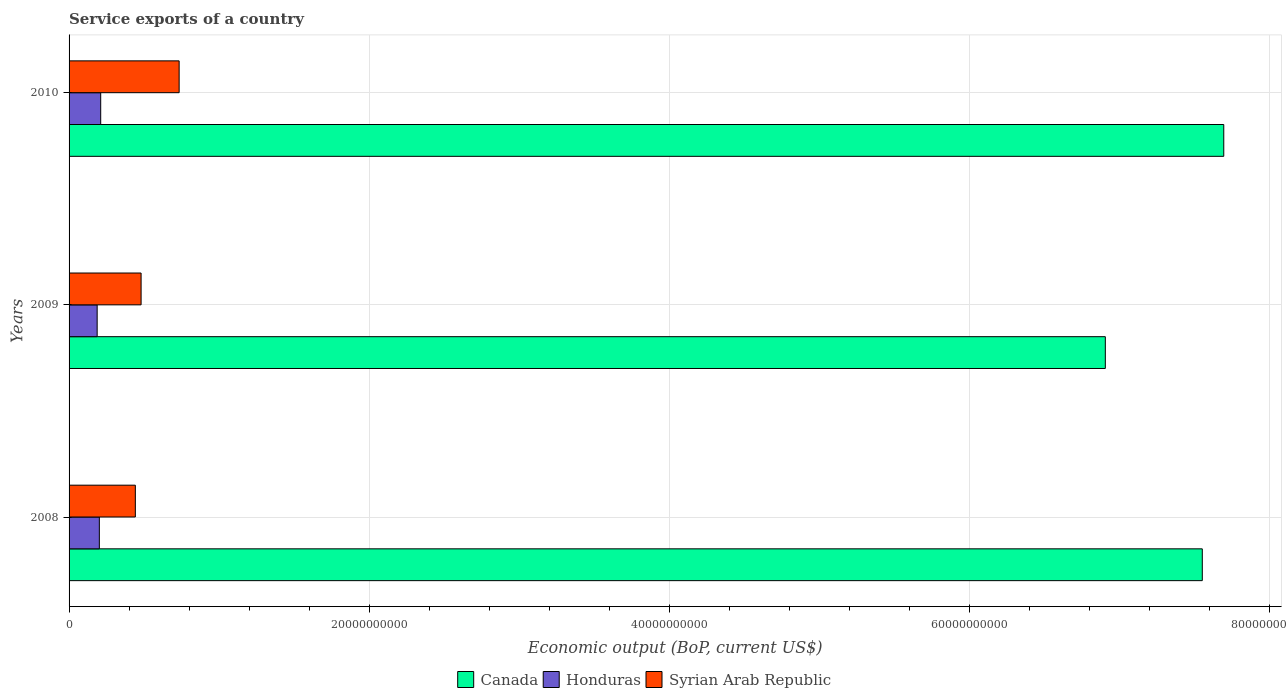How many different coloured bars are there?
Offer a very short reply. 3. Are the number of bars per tick equal to the number of legend labels?
Make the answer very short. Yes. How many bars are there on the 1st tick from the bottom?
Offer a very short reply. 3. What is the service exports in Canada in 2008?
Make the answer very short. 7.55e+1. Across all years, what is the maximum service exports in Canada?
Offer a very short reply. 7.69e+1. Across all years, what is the minimum service exports in Syrian Arab Republic?
Provide a succinct answer. 4.42e+09. In which year was the service exports in Canada maximum?
Ensure brevity in your answer.  2010. What is the total service exports in Honduras in the graph?
Offer a very short reply. 6.00e+09. What is the difference between the service exports in Canada in 2008 and that in 2010?
Keep it short and to the point. -1.43e+09. What is the difference between the service exports in Canada in 2010 and the service exports in Syrian Arab Republic in 2009?
Your answer should be compact. 7.21e+1. What is the average service exports in Canada per year?
Ensure brevity in your answer.  7.38e+1. In the year 2009, what is the difference between the service exports in Canada and service exports in Honduras?
Provide a short and direct response. 6.72e+1. What is the ratio of the service exports in Canada in 2008 to that in 2009?
Your answer should be compact. 1.09. Is the service exports in Syrian Arab Republic in 2008 less than that in 2010?
Your answer should be compact. Yes. What is the difference between the highest and the second highest service exports in Canada?
Offer a very short reply. 1.43e+09. What is the difference between the highest and the lowest service exports in Syrian Arab Republic?
Keep it short and to the point. 2.92e+09. In how many years, is the service exports in Syrian Arab Republic greater than the average service exports in Syrian Arab Republic taken over all years?
Give a very brief answer. 1. Is the sum of the service exports in Syrian Arab Republic in 2008 and 2010 greater than the maximum service exports in Honduras across all years?
Provide a succinct answer. Yes. What does the 3rd bar from the top in 2010 represents?
Your answer should be very brief. Canada. What does the 1st bar from the bottom in 2009 represents?
Provide a succinct answer. Canada. How many bars are there?
Provide a short and direct response. 9. Are all the bars in the graph horizontal?
Offer a terse response. Yes. Are the values on the major ticks of X-axis written in scientific E-notation?
Ensure brevity in your answer.  No. How are the legend labels stacked?
Make the answer very short. Horizontal. What is the title of the graph?
Offer a very short reply. Service exports of a country. Does "Nepal" appear as one of the legend labels in the graph?
Your answer should be compact. No. What is the label or title of the X-axis?
Give a very brief answer. Economic output (BoP, current US$). What is the label or title of the Y-axis?
Give a very brief answer. Years. What is the Economic output (BoP, current US$) in Canada in 2008?
Ensure brevity in your answer.  7.55e+1. What is the Economic output (BoP, current US$) in Honduras in 2008?
Your answer should be very brief. 2.02e+09. What is the Economic output (BoP, current US$) of Syrian Arab Republic in 2008?
Give a very brief answer. 4.42e+09. What is the Economic output (BoP, current US$) of Canada in 2009?
Your answer should be very brief. 6.90e+1. What is the Economic output (BoP, current US$) of Honduras in 2009?
Give a very brief answer. 1.87e+09. What is the Economic output (BoP, current US$) in Syrian Arab Republic in 2009?
Provide a succinct answer. 4.80e+09. What is the Economic output (BoP, current US$) in Canada in 2010?
Give a very brief answer. 7.69e+1. What is the Economic output (BoP, current US$) of Honduras in 2010?
Offer a terse response. 2.11e+09. What is the Economic output (BoP, current US$) in Syrian Arab Republic in 2010?
Provide a short and direct response. 7.33e+09. Across all years, what is the maximum Economic output (BoP, current US$) of Canada?
Your answer should be compact. 7.69e+1. Across all years, what is the maximum Economic output (BoP, current US$) in Honduras?
Provide a succinct answer. 2.11e+09. Across all years, what is the maximum Economic output (BoP, current US$) in Syrian Arab Republic?
Keep it short and to the point. 7.33e+09. Across all years, what is the minimum Economic output (BoP, current US$) in Canada?
Your answer should be compact. 6.90e+1. Across all years, what is the minimum Economic output (BoP, current US$) in Honduras?
Your answer should be very brief. 1.87e+09. Across all years, what is the minimum Economic output (BoP, current US$) in Syrian Arab Republic?
Offer a terse response. 4.42e+09. What is the total Economic output (BoP, current US$) in Canada in the graph?
Keep it short and to the point. 2.21e+11. What is the total Economic output (BoP, current US$) of Honduras in the graph?
Provide a short and direct response. 6.00e+09. What is the total Economic output (BoP, current US$) in Syrian Arab Republic in the graph?
Give a very brief answer. 1.65e+1. What is the difference between the Economic output (BoP, current US$) of Canada in 2008 and that in 2009?
Make the answer very short. 6.46e+09. What is the difference between the Economic output (BoP, current US$) of Honduras in 2008 and that in 2009?
Offer a terse response. 1.46e+08. What is the difference between the Economic output (BoP, current US$) in Syrian Arab Republic in 2008 and that in 2009?
Give a very brief answer. -3.83e+08. What is the difference between the Economic output (BoP, current US$) in Canada in 2008 and that in 2010?
Provide a short and direct response. -1.43e+09. What is the difference between the Economic output (BoP, current US$) in Honduras in 2008 and that in 2010?
Give a very brief answer. -9.05e+07. What is the difference between the Economic output (BoP, current US$) of Syrian Arab Republic in 2008 and that in 2010?
Provide a short and direct response. -2.92e+09. What is the difference between the Economic output (BoP, current US$) of Canada in 2009 and that in 2010?
Provide a succinct answer. -7.89e+09. What is the difference between the Economic output (BoP, current US$) of Honduras in 2009 and that in 2010?
Your response must be concise. -2.36e+08. What is the difference between the Economic output (BoP, current US$) in Syrian Arab Republic in 2009 and that in 2010?
Provide a succinct answer. -2.53e+09. What is the difference between the Economic output (BoP, current US$) of Canada in 2008 and the Economic output (BoP, current US$) of Honduras in 2009?
Offer a very short reply. 7.36e+1. What is the difference between the Economic output (BoP, current US$) of Canada in 2008 and the Economic output (BoP, current US$) of Syrian Arab Republic in 2009?
Ensure brevity in your answer.  7.07e+1. What is the difference between the Economic output (BoP, current US$) in Honduras in 2008 and the Economic output (BoP, current US$) in Syrian Arab Republic in 2009?
Provide a succinct answer. -2.78e+09. What is the difference between the Economic output (BoP, current US$) of Canada in 2008 and the Economic output (BoP, current US$) of Honduras in 2010?
Offer a very short reply. 7.34e+1. What is the difference between the Economic output (BoP, current US$) in Canada in 2008 and the Economic output (BoP, current US$) in Syrian Arab Republic in 2010?
Your answer should be very brief. 6.82e+1. What is the difference between the Economic output (BoP, current US$) of Honduras in 2008 and the Economic output (BoP, current US$) of Syrian Arab Republic in 2010?
Provide a succinct answer. -5.32e+09. What is the difference between the Economic output (BoP, current US$) of Canada in 2009 and the Economic output (BoP, current US$) of Honduras in 2010?
Your answer should be compact. 6.69e+1. What is the difference between the Economic output (BoP, current US$) of Canada in 2009 and the Economic output (BoP, current US$) of Syrian Arab Republic in 2010?
Make the answer very short. 6.17e+1. What is the difference between the Economic output (BoP, current US$) of Honduras in 2009 and the Economic output (BoP, current US$) of Syrian Arab Republic in 2010?
Make the answer very short. -5.46e+09. What is the average Economic output (BoP, current US$) in Canada per year?
Give a very brief answer. 7.38e+1. What is the average Economic output (BoP, current US$) in Honduras per year?
Offer a terse response. 2.00e+09. What is the average Economic output (BoP, current US$) in Syrian Arab Republic per year?
Keep it short and to the point. 5.52e+09. In the year 2008, what is the difference between the Economic output (BoP, current US$) in Canada and Economic output (BoP, current US$) in Honduras?
Provide a short and direct response. 7.35e+1. In the year 2008, what is the difference between the Economic output (BoP, current US$) of Canada and Economic output (BoP, current US$) of Syrian Arab Republic?
Offer a very short reply. 7.11e+1. In the year 2008, what is the difference between the Economic output (BoP, current US$) of Honduras and Economic output (BoP, current US$) of Syrian Arab Republic?
Your response must be concise. -2.40e+09. In the year 2009, what is the difference between the Economic output (BoP, current US$) of Canada and Economic output (BoP, current US$) of Honduras?
Your response must be concise. 6.72e+1. In the year 2009, what is the difference between the Economic output (BoP, current US$) in Canada and Economic output (BoP, current US$) in Syrian Arab Republic?
Your answer should be very brief. 6.42e+1. In the year 2009, what is the difference between the Economic output (BoP, current US$) in Honduras and Economic output (BoP, current US$) in Syrian Arab Republic?
Your response must be concise. -2.93e+09. In the year 2010, what is the difference between the Economic output (BoP, current US$) of Canada and Economic output (BoP, current US$) of Honduras?
Keep it short and to the point. 7.48e+1. In the year 2010, what is the difference between the Economic output (BoP, current US$) in Canada and Economic output (BoP, current US$) in Syrian Arab Republic?
Ensure brevity in your answer.  6.96e+1. In the year 2010, what is the difference between the Economic output (BoP, current US$) in Honduras and Economic output (BoP, current US$) in Syrian Arab Republic?
Your answer should be compact. -5.23e+09. What is the ratio of the Economic output (BoP, current US$) in Canada in 2008 to that in 2009?
Keep it short and to the point. 1.09. What is the ratio of the Economic output (BoP, current US$) in Honduras in 2008 to that in 2009?
Offer a terse response. 1.08. What is the ratio of the Economic output (BoP, current US$) in Syrian Arab Republic in 2008 to that in 2009?
Offer a very short reply. 0.92. What is the ratio of the Economic output (BoP, current US$) in Canada in 2008 to that in 2010?
Your response must be concise. 0.98. What is the ratio of the Economic output (BoP, current US$) of Syrian Arab Republic in 2008 to that in 2010?
Provide a succinct answer. 0.6. What is the ratio of the Economic output (BoP, current US$) of Canada in 2009 to that in 2010?
Your response must be concise. 0.9. What is the ratio of the Economic output (BoP, current US$) of Honduras in 2009 to that in 2010?
Ensure brevity in your answer.  0.89. What is the ratio of the Economic output (BoP, current US$) of Syrian Arab Republic in 2009 to that in 2010?
Offer a very short reply. 0.65. What is the difference between the highest and the second highest Economic output (BoP, current US$) of Canada?
Give a very brief answer. 1.43e+09. What is the difference between the highest and the second highest Economic output (BoP, current US$) in Honduras?
Offer a terse response. 9.05e+07. What is the difference between the highest and the second highest Economic output (BoP, current US$) in Syrian Arab Republic?
Provide a short and direct response. 2.53e+09. What is the difference between the highest and the lowest Economic output (BoP, current US$) in Canada?
Your answer should be very brief. 7.89e+09. What is the difference between the highest and the lowest Economic output (BoP, current US$) of Honduras?
Provide a succinct answer. 2.36e+08. What is the difference between the highest and the lowest Economic output (BoP, current US$) of Syrian Arab Republic?
Give a very brief answer. 2.92e+09. 